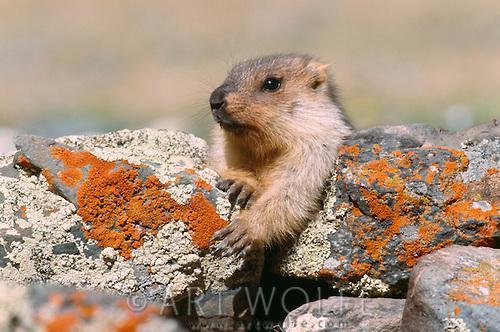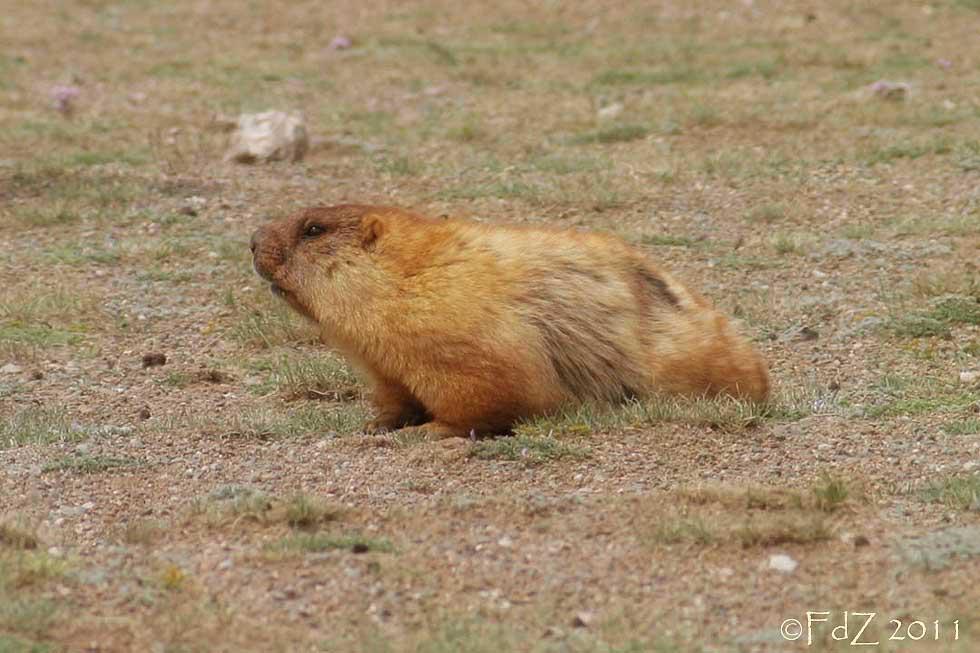The first image is the image on the left, the second image is the image on the right. Assess this claim about the two images: "Each image contains exactly one prairie dog type animal.". Correct or not? Answer yes or no. Yes. The first image is the image on the left, the second image is the image on the right. Evaluate the accuracy of this statement regarding the images: "There are no less than three animals". Is it true? Answer yes or no. No. 